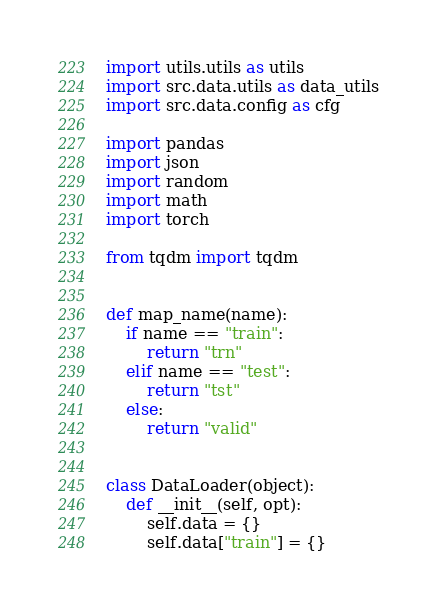Convert code to text. <code><loc_0><loc_0><loc_500><loc_500><_Python_>import utils.utils as utils
import src.data.utils as data_utils
import src.data.config as cfg

import pandas
import json
import random
import math
import torch

from tqdm import tqdm


def map_name(name):
    if name == "train":
        return "trn"
    elif name == "test":
        return "tst"
    else:
        return "valid"


class DataLoader(object):
    def __init__(self, opt):
        self.data = {}
        self.data["train"] = {}</code> 